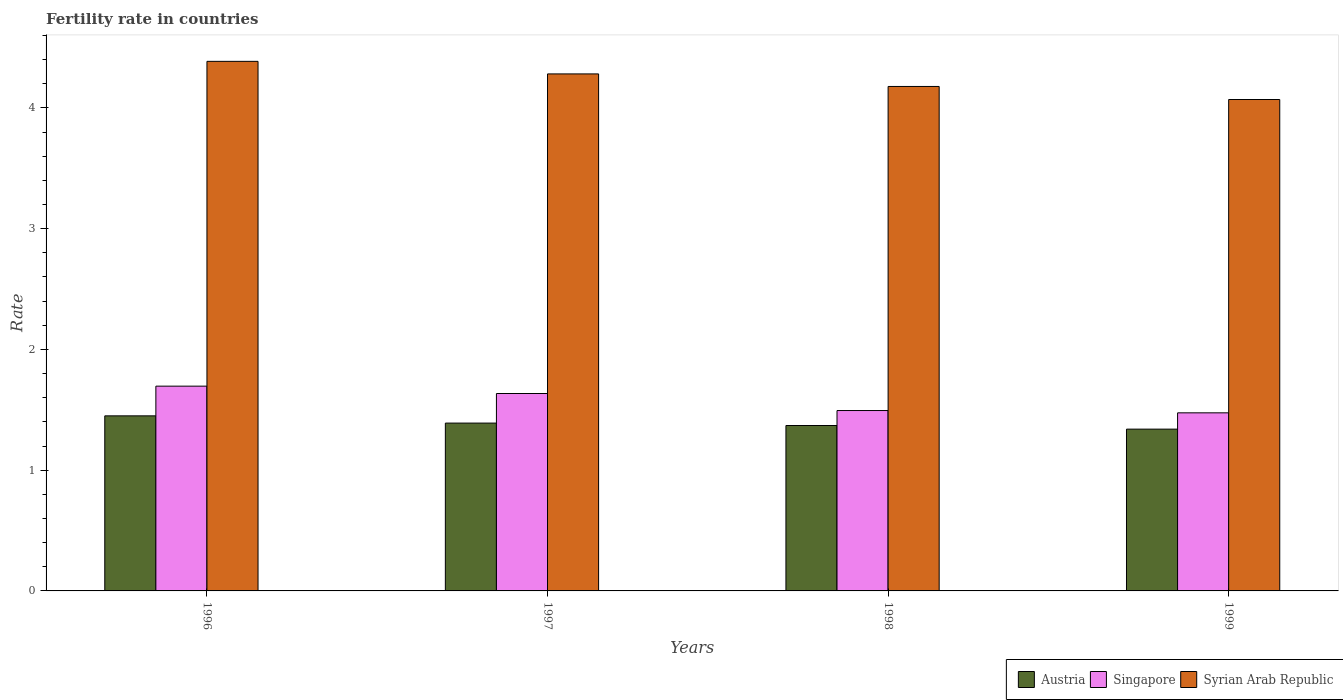How many groups of bars are there?
Offer a terse response. 4. Are the number of bars on each tick of the X-axis equal?
Your response must be concise. Yes. What is the fertility rate in Syrian Arab Republic in 1997?
Provide a short and direct response. 4.28. Across all years, what is the maximum fertility rate in Syrian Arab Republic?
Offer a very short reply. 4.39. Across all years, what is the minimum fertility rate in Singapore?
Give a very brief answer. 1.48. In which year was the fertility rate in Austria maximum?
Your response must be concise. 1996. What is the total fertility rate in Singapore in the graph?
Provide a succinct answer. 6.3. What is the difference between the fertility rate in Syrian Arab Republic in 1997 and that in 1999?
Offer a very short reply. 0.21. What is the difference between the fertility rate in Singapore in 1997 and the fertility rate in Austria in 1998?
Give a very brief answer. 0.26. What is the average fertility rate in Austria per year?
Provide a short and direct response. 1.39. In the year 1997, what is the difference between the fertility rate in Singapore and fertility rate in Austria?
Offer a very short reply. 0.25. What is the ratio of the fertility rate in Austria in 1996 to that in 1997?
Provide a succinct answer. 1.04. Is the difference between the fertility rate in Singapore in 1998 and 1999 greater than the difference between the fertility rate in Austria in 1998 and 1999?
Ensure brevity in your answer.  No. What is the difference between the highest and the second highest fertility rate in Austria?
Your answer should be very brief. 0.06. What is the difference between the highest and the lowest fertility rate in Syrian Arab Republic?
Your answer should be very brief. 0.32. In how many years, is the fertility rate in Austria greater than the average fertility rate in Austria taken over all years?
Your response must be concise. 2. Is the sum of the fertility rate in Syrian Arab Republic in 1996 and 1998 greater than the maximum fertility rate in Singapore across all years?
Ensure brevity in your answer.  Yes. What does the 2nd bar from the left in 1999 represents?
Keep it short and to the point. Singapore. What does the 1st bar from the right in 1999 represents?
Provide a short and direct response. Syrian Arab Republic. Is it the case that in every year, the sum of the fertility rate in Syrian Arab Republic and fertility rate in Singapore is greater than the fertility rate in Austria?
Your answer should be compact. Yes. How many bars are there?
Your response must be concise. 12. What is the difference between two consecutive major ticks on the Y-axis?
Your answer should be compact. 1. Does the graph contain grids?
Keep it short and to the point. No. How many legend labels are there?
Make the answer very short. 3. How are the legend labels stacked?
Ensure brevity in your answer.  Horizontal. What is the title of the graph?
Provide a succinct answer. Fertility rate in countries. Does "Saudi Arabia" appear as one of the legend labels in the graph?
Offer a terse response. No. What is the label or title of the X-axis?
Your answer should be very brief. Years. What is the label or title of the Y-axis?
Your response must be concise. Rate. What is the Rate of Austria in 1996?
Offer a very short reply. 1.45. What is the Rate in Singapore in 1996?
Your answer should be very brief. 1.7. What is the Rate in Syrian Arab Republic in 1996?
Make the answer very short. 4.39. What is the Rate in Austria in 1997?
Your response must be concise. 1.39. What is the Rate of Singapore in 1997?
Offer a terse response. 1.64. What is the Rate of Syrian Arab Republic in 1997?
Your answer should be compact. 4.28. What is the Rate of Austria in 1998?
Ensure brevity in your answer.  1.37. What is the Rate in Singapore in 1998?
Your answer should be compact. 1.49. What is the Rate in Syrian Arab Republic in 1998?
Make the answer very short. 4.18. What is the Rate in Austria in 1999?
Offer a terse response. 1.34. What is the Rate in Singapore in 1999?
Make the answer very short. 1.48. What is the Rate in Syrian Arab Republic in 1999?
Provide a succinct answer. 4.07. Across all years, what is the maximum Rate in Austria?
Provide a succinct answer. 1.45. Across all years, what is the maximum Rate in Singapore?
Offer a very short reply. 1.7. Across all years, what is the maximum Rate in Syrian Arab Republic?
Your response must be concise. 4.39. Across all years, what is the minimum Rate of Austria?
Provide a short and direct response. 1.34. Across all years, what is the minimum Rate of Singapore?
Your answer should be very brief. 1.48. Across all years, what is the minimum Rate of Syrian Arab Republic?
Give a very brief answer. 4.07. What is the total Rate in Austria in the graph?
Your answer should be very brief. 5.55. What is the total Rate in Syrian Arab Republic in the graph?
Provide a succinct answer. 16.92. What is the difference between the Rate in Austria in 1996 and that in 1997?
Provide a short and direct response. 0.06. What is the difference between the Rate in Singapore in 1996 and that in 1997?
Your response must be concise. 0.06. What is the difference between the Rate in Syrian Arab Republic in 1996 and that in 1997?
Your answer should be very brief. 0.1. What is the difference between the Rate of Austria in 1996 and that in 1998?
Ensure brevity in your answer.  0.08. What is the difference between the Rate of Singapore in 1996 and that in 1998?
Your answer should be very brief. 0.2. What is the difference between the Rate in Syrian Arab Republic in 1996 and that in 1998?
Offer a very short reply. 0.21. What is the difference between the Rate in Austria in 1996 and that in 1999?
Ensure brevity in your answer.  0.11. What is the difference between the Rate in Singapore in 1996 and that in 1999?
Make the answer very short. 0.22. What is the difference between the Rate in Syrian Arab Republic in 1996 and that in 1999?
Offer a terse response. 0.32. What is the difference between the Rate of Austria in 1997 and that in 1998?
Provide a short and direct response. 0.02. What is the difference between the Rate in Singapore in 1997 and that in 1998?
Ensure brevity in your answer.  0.14. What is the difference between the Rate of Syrian Arab Republic in 1997 and that in 1998?
Your answer should be very brief. 0.1. What is the difference between the Rate in Austria in 1997 and that in 1999?
Provide a succinct answer. 0.05. What is the difference between the Rate of Singapore in 1997 and that in 1999?
Keep it short and to the point. 0.16. What is the difference between the Rate in Syrian Arab Republic in 1997 and that in 1999?
Offer a very short reply. 0.21. What is the difference between the Rate in Austria in 1998 and that in 1999?
Your answer should be compact. 0.03. What is the difference between the Rate of Singapore in 1998 and that in 1999?
Offer a terse response. 0.02. What is the difference between the Rate in Syrian Arab Republic in 1998 and that in 1999?
Provide a short and direct response. 0.11. What is the difference between the Rate in Austria in 1996 and the Rate in Singapore in 1997?
Make the answer very short. -0.18. What is the difference between the Rate of Austria in 1996 and the Rate of Syrian Arab Republic in 1997?
Your answer should be compact. -2.83. What is the difference between the Rate of Singapore in 1996 and the Rate of Syrian Arab Republic in 1997?
Your response must be concise. -2.59. What is the difference between the Rate in Austria in 1996 and the Rate in Singapore in 1998?
Give a very brief answer. -0.04. What is the difference between the Rate in Austria in 1996 and the Rate in Syrian Arab Republic in 1998?
Give a very brief answer. -2.73. What is the difference between the Rate of Singapore in 1996 and the Rate of Syrian Arab Republic in 1998?
Keep it short and to the point. -2.48. What is the difference between the Rate of Austria in 1996 and the Rate of Singapore in 1999?
Your response must be concise. -0.03. What is the difference between the Rate in Austria in 1996 and the Rate in Syrian Arab Republic in 1999?
Offer a terse response. -2.62. What is the difference between the Rate of Singapore in 1996 and the Rate of Syrian Arab Republic in 1999?
Give a very brief answer. -2.37. What is the difference between the Rate in Austria in 1997 and the Rate in Singapore in 1998?
Your answer should be compact. -0.1. What is the difference between the Rate of Austria in 1997 and the Rate of Syrian Arab Republic in 1998?
Ensure brevity in your answer.  -2.79. What is the difference between the Rate in Singapore in 1997 and the Rate in Syrian Arab Republic in 1998?
Ensure brevity in your answer.  -2.54. What is the difference between the Rate of Austria in 1997 and the Rate of Singapore in 1999?
Provide a short and direct response. -0.09. What is the difference between the Rate of Austria in 1997 and the Rate of Syrian Arab Republic in 1999?
Ensure brevity in your answer.  -2.68. What is the difference between the Rate in Singapore in 1997 and the Rate in Syrian Arab Republic in 1999?
Offer a very short reply. -2.44. What is the difference between the Rate of Austria in 1998 and the Rate of Singapore in 1999?
Provide a short and direct response. -0.1. What is the difference between the Rate in Austria in 1998 and the Rate in Syrian Arab Republic in 1999?
Provide a succinct answer. -2.7. What is the difference between the Rate of Singapore in 1998 and the Rate of Syrian Arab Republic in 1999?
Ensure brevity in your answer.  -2.58. What is the average Rate in Austria per year?
Provide a short and direct response. 1.39. What is the average Rate of Singapore per year?
Give a very brief answer. 1.57. What is the average Rate in Syrian Arab Republic per year?
Your answer should be very brief. 4.23. In the year 1996, what is the difference between the Rate of Austria and Rate of Singapore?
Give a very brief answer. -0.25. In the year 1996, what is the difference between the Rate in Austria and Rate in Syrian Arab Republic?
Make the answer very short. -2.94. In the year 1996, what is the difference between the Rate of Singapore and Rate of Syrian Arab Republic?
Offer a very short reply. -2.69. In the year 1997, what is the difference between the Rate in Austria and Rate in Singapore?
Your response must be concise. -0.24. In the year 1997, what is the difference between the Rate of Austria and Rate of Syrian Arab Republic?
Provide a short and direct response. -2.89. In the year 1997, what is the difference between the Rate of Singapore and Rate of Syrian Arab Republic?
Offer a terse response. -2.65. In the year 1998, what is the difference between the Rate of Austria and Rate of Singapore?
Your answer should be compact. -0.12. In the year 1998, what is the difference between the Rate of Austria and Rate of Syrian Arab Republic?
Make the answer very short. -2.81. In the year 1998, what is the difference between the Rate of Singapore and Rate of Syrian Arab Republic?
Your response must be concise. -2.68. In the year 1999, what is the difference between the Rate of Austria and Rate of Singapore?
Give a very brief answer. -0.14. In the year 1999, what is the difference between the Rate of Austria and Rate of Syrian Arab Republic?
Your response must be concise. -2.73. In the year 1999, what is the difference between the Rate of Singapore and Rate of Syrian Arab Republic?
Provide a short and direct response. -2.6. What is the ratio of the Rate of Austria in 1996 to that in 1997?
Your response must be concise. 1.04. What is the ratio of the Rate in Singapore in 1996 to that in 1997?
Your answer should be very brief. 1.04. What is the ratio of the Rate in Syrian Arab Republic in 1996 to that in 1997?
Provide a short and direct response. 1.02. What is the ratio of the Rate of Austria in 1996 to that in 1998?
Provide a succinct answer. 1.06. What is the ratio of the Rate in Singapore in 1996 to that in 1998?
Offer a terse response. 1.14. What is the ratio of the Rate of Syrian Arab Republic in 1996 to that in 1998?
Your response must be concise. 1.05. What is the ratio of the Rate in Austria in 1996 to that in 1999?
Your response must be concise. 1.08. What is the ratio of the Rate in Singapore in 1996 to that in 1999?
Make the answer very short. 1.15. What is the ratio of the Rate in Syrian Arab Republic in 1996 to that in 1999?
Ensure brevity in your answer.  1.08. What is the ratio of the Rate in Austria in 1997 to that in 1998?
Make the answer very short. 1.01. What is the ratio of the Rate in Singapore in 1997 to that in 1998?
Offer a terse response. 1.09. What is the ratio of the Rate of Syrian Arab Republic in 1997 to that in 1998?
Your response must be concise. 1.02. What is the ratio of the Rate of Austria in 1997 to that in 1999?
Ensure brevity in your answer.  1.04. What is the ratio of the Rate in Singapore in 1997 to that in 1999?
Your answer should be very brief. 1.11. What is the ratio of the Rate of Syrian Arab Republic in 1997 to that in 1999?
Your answer should be very brief. 1.05. What is the ratio of the Rate in Austria in 1998 to that in 1999?
Keep it short and to the point. 1.02. What is the ratio of the Rate in Singapore in 1998 to that in 1999?
Make the answer very short. 1.01. What is the ratio of the Rate in Syrian Arab Republic in 1998 to that in 1999?
Give a very brief answer. 1.03. What is the difference between the highest and the second highest Rate in Austria?
Provide a short and direct response. 0.06. What is the difference between the highest and the second highest Rate in Singapore?
Ensure brevity in your answer.  0.06. What is the difference between the highest and the second highest Rate in Syrian Arab Republic?
Your response must be concise. 0.1. What is the difference between the highest and the lowest Rate of Austria?
Your answer should be very brief. 0.11. What is the difference between the highest and the lowest Rate of Singapore?
Ensure brevity in your answer.  0.22. What is the difference between the highest and the lowest Rate of Syrian Arab Republic?
Offer a very short reply. 0.32. 